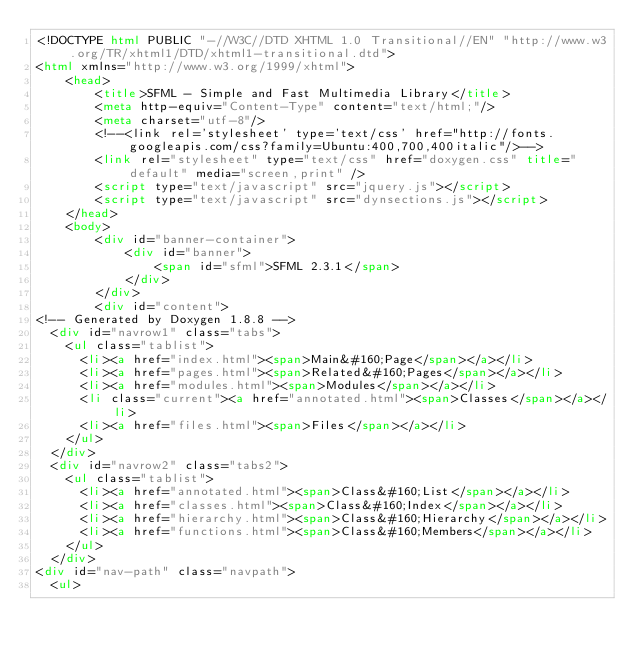Convert code to text. <code><loc_0><loc_0><loc_500><loc_500><_HTML_><!DOCTYPE html PUBLIC "-//W3C//DTD XHTML 1.0 Transitional//EN" "http://www.w3.org/TR/xhtml1/DTD/xhtml1-transitional.dtd">
<html xmlns="http://www.w3.org/1999/xhtml">
    <head>
        <title>SFML - Simple and Fast Multimedia Library</title>
        <meta http-equiv="Content-Type" content="text/html;"/>
        <meta charset="utf-8"/>
        <!--<link rel='stylesheet' type='text/css' href="http://fonts.googleapis.com/css?family=Ubuntu:400,700,400italic"/>-->
        <link rel="stylesheet" type="text/css" href="doxygen.css" title="default" media="screen,print" />
        <script type="text/javascript" src="jquery.js"></script>
        <script type="text/javascript" src="dynsections.js"></script>
    </head>
    <body>
        <div id="banner-container">
            <div id="banner">
                <span id="sfml">SFML 2.3.1</span>
            </div>
        </div>
        <div id="content">
<!-- Generated by Doxygen 1.8.8 -->
  <div id="navrow1" class="tabs">
    <ul class="tablist">
      <li><a href="index.html"><span>Main&#160;Page</span></a></li>
      <li><a href="pages.html"><span>Related&#160;Pages</span></a></li>
      <li><a href="modules.html"><span>Modules</span></a></li>
      <li class="current"><a href="annotated.html"><span>Classes</span></a></li>
      <li><a href="files.html"><span>Files</span></a></li>
    </ul>
  </div>
  <div id="navrow2" class="tabs2">
    <ul class="tablist">
      <li><a href="annotated.html"><span>Class&#160;List</span></a></li>
      <li><a href="classes.html"><span>Class&#160;Index</span></a></li>
      <li><a href="hierarchy.html"><span>Class&#160;Hierarchy</span></a></li>
      <li><a href="functions.html"><span>Class&#160;Members</span></a></li>
    </ul>
  </div>
<div id="nav-path" class="navpath">
  <ul></code> 